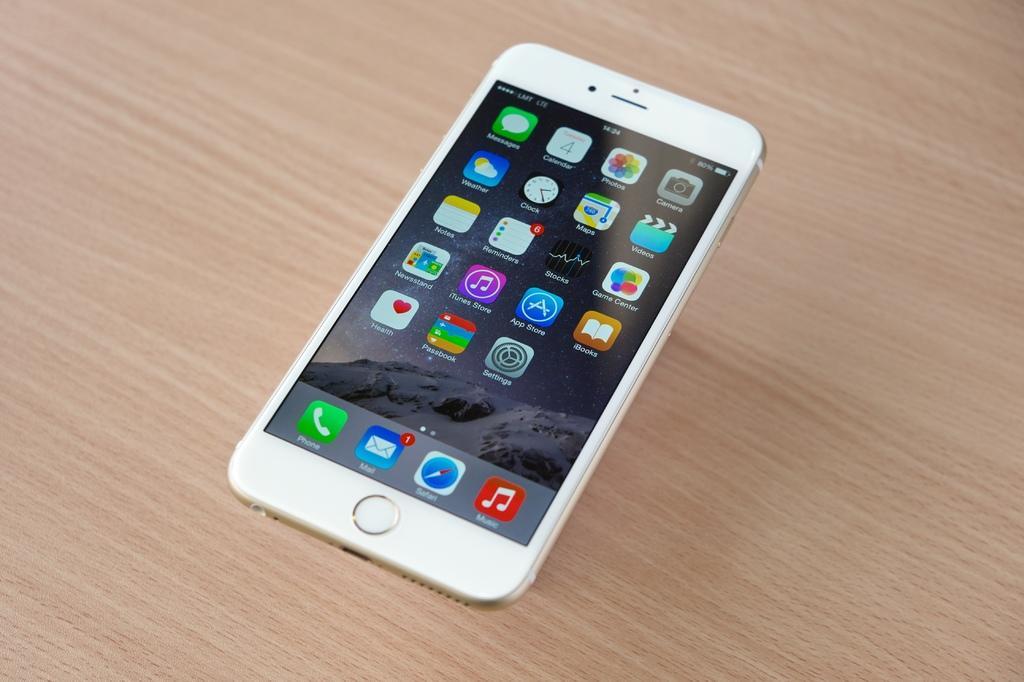Can you describe this image briefly? In this picture we can see a wooden surface. On a wooden surface we can see a mobile. We can see the display of applications. 